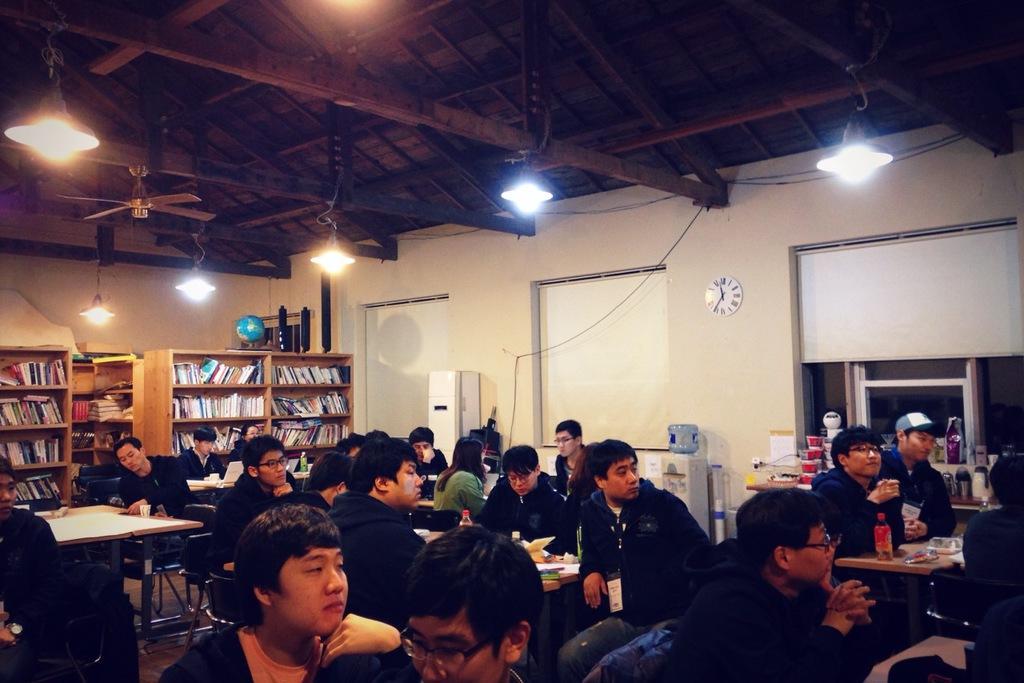Please provide a concise description of this image. In this image in front there are people sitting on the chairs. In front of them there are tables and on top of the tables there are water bottles and few other objects. Behind them there is a wooden rack with the books in it. On top of the rock there is a globe. On the backside there is a wall with the wall clock on it. In front of the wall there is a water filter. On top of the roof there are lights and a fan. 